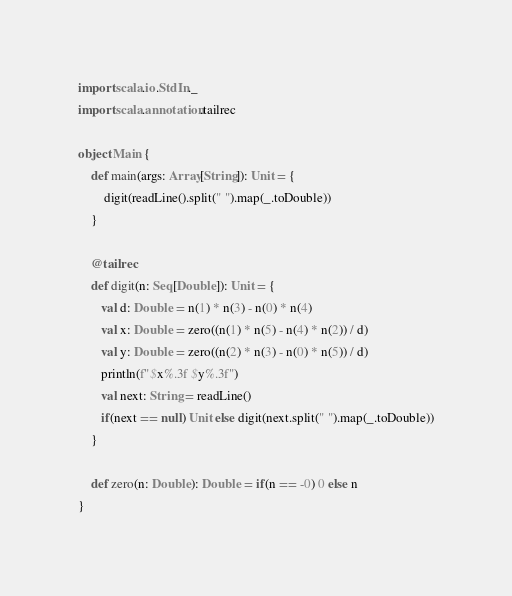Convert code to text. <code><loc_0><loc_0><loc_500><loc_500><_Scala_>import scala.io.StdIn._
import scala.annotation.tailrec

object Main {
    def main(args: Array[String]): Unit = { 
        digit(readLine().split(" ").map(_.toDouble))
    }   

    @tailrec
    def digit(n: Seq[Double]): Unit = {
       val d: Double = n(1) * n(3) - n(0) * n(4)
       val x: Double = zero((n(1) * n(5) - n(4) * n(2)) / d)
       val y: Double = zero((n(2) * n(3) - n(0) * n(5)) / d)
       println(f"$x%.3f $y%.3f")
       val next: String = readLine()
       if(next == null) Unit else digit(next.split(" ").map(_.toDouble))
    }

    def zero(n: Double): Double = if(n == -0) 0 else n
}</code> 